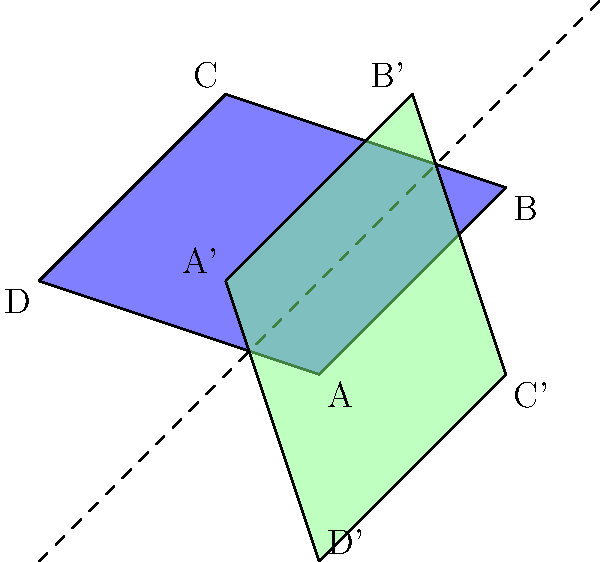As a young aspiring politician, you're analyzing a proposed redistricting plan. The original voting district is represented by the quadrilateral ABCD in the coordinate plane. If this district is reflected across the line $y=x$, what will be the coordinates of point C' (the reflection of point C)? To find the coordinates of point C' after reflection across the line $y=x$, we can follow these steps:

1. Identify the original coordinates of point C: $(1, 4)$

2. The line of reflection is $y=x$, which means we need to swap the x and y coordinates.

3. After swapping, the new coordinates would be $(4, 1)$

4. However, this is not the final answer. Reflection across $y=x$ also involves changing the signs of both coordinates.

5. Therefore, the final coordinates of C' are $(4, 1)$

This reflection process can be summarized by the following transformation:
For any point $(a, b)$, its reflection across $y=x$ is $(b, a)$.

We can verify this by looking at the other points:
A $(2, 1)$ becomes A' $(1, 2)$
B $(4, 3)$ becomes B' $(3, 4)$
D $(-1, 2)$ becomes D' $(2, -1)$

This transformation preserves the shape and size of the district while changing its orientation, which is a key property of reflections that aspiring politicians should understand when analyzing redistricting plans.
Answer: $(4, 1)$ 